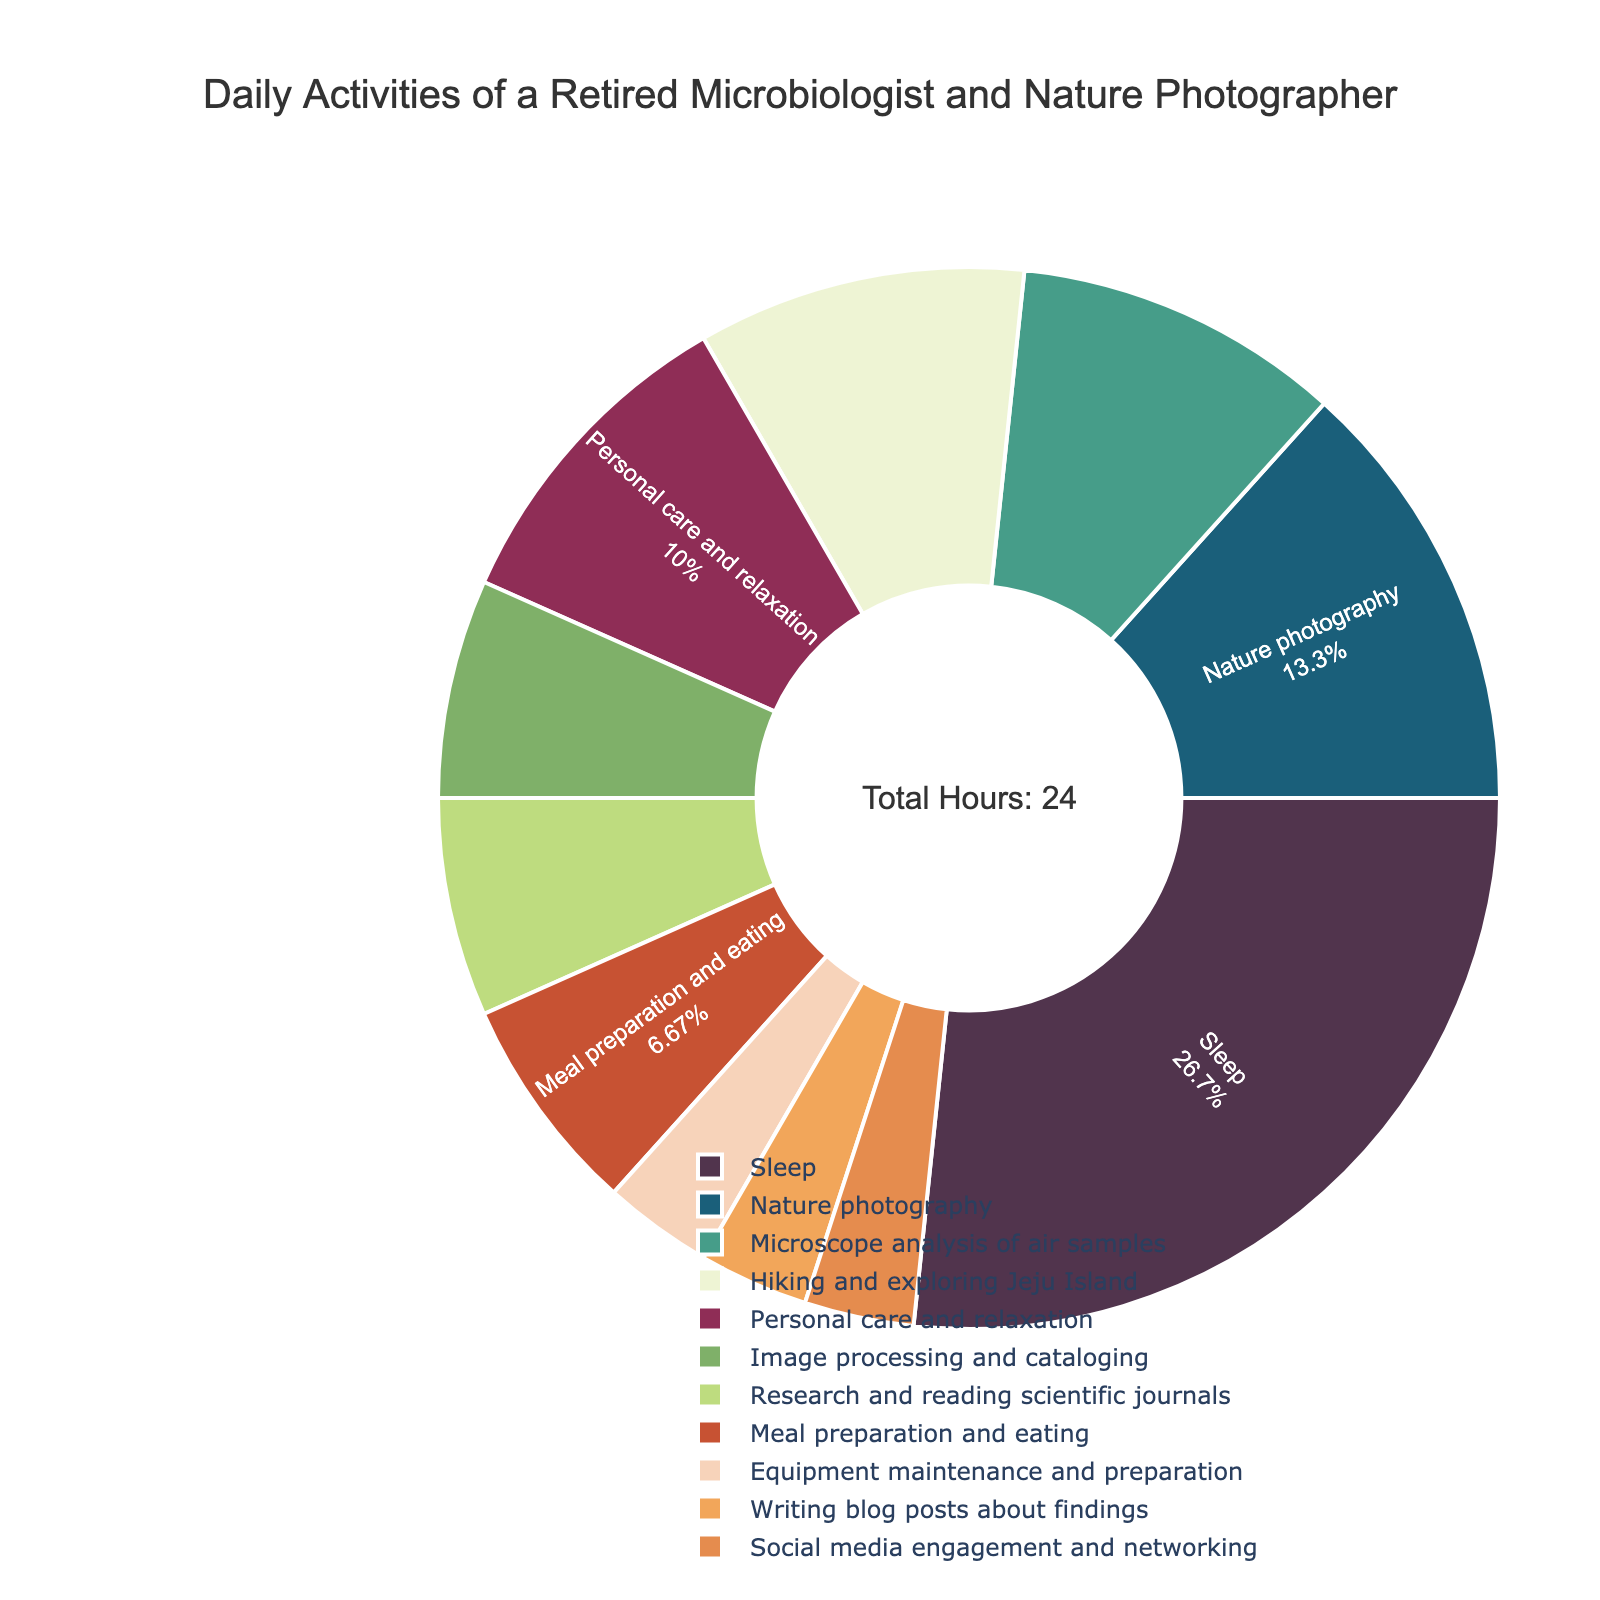what activity takes up the most time during the day? By looking at the size of the segments in the pie chart, we can see that the "Sleep" activity occupies the largest section of the pie, indicating it takes up the most time during the day.
Answer: Sleep How many total hours are spent on professional activities? To find the total hours spent on professional activities, we add up the hours of nature photography, microscope analysis, image processing, research and reading, equipment maintenance, and writing blog posts: 4 + 3 + 2 + 2 + 1 + 1 = 13 hours.
Answer: 13 hours Which activity is allocated less time: hiking and exploring Jeju Island or personal care and relaxation? By comparing the sections in the pie chart, we see that both "Hiking and exploring Jeju Island" and "Personal care and relaxation" have similar sizes. However, each is allocated 3 hours, making them equal.
Answer: They are equal What is the total percentage of time spent on 'Social media engagement and networking' combined with 'Meal preparation and eating'? The chart shows the proportion of time spent on each activity. To find the combined percentage, we add their individual percentages (1 hour of social media and 2 hours of meal prep). Since the total hours are 24, (1/24) * 100 + (2/24) * 100 = 4.17% + 8.33% = 12.5%.
Answer: 12.5% Which activity is represented by the green section of the pie chart? According to the color scheme provided, the green section represents "Microscope analysis of air samples".
Answer: Microscope analysis of air samples How does the time spent on 'Nature photography' compare to 'Meal preparation and eating'? From the pie chart, we can see that "Nature photography" occupies a larger section than "Meal preparation and eating". Specifically, nature photography takes up 4 hours, whereas meal preparation and eating take up 2 hours.
Answer: Nature photography takes more time If you combined 'Research and reading scientific journals' and 'Writing blog posts about findings', how many hours in total would you have? By adding the hours spent on each activity (2 hours for research and reading, 1 hour for writing blog posts), we get 2 + 1 = 3 hours in total.
Answer: 3 hours What is the proportion of time spent on 'Microscope analysis of air samples' relative to 'Nature photography'? To find the proportion, divide the hours spent on microscope analysis (3 hours) by the hours spent on nature photography (4 hours): 3/4 = 0.75, or 75%.
Answer: 75% Which activities together make up exactly half of the day's time? By examining the chart, we can sum up the hours to see which combination equals 12 hours. Sleep (8 hours) combined with Nature photography (4 hours) make up 8 + 4 = 12 hours, which is exactly half of the day's time.
Answer: Sleep and Nature photography 